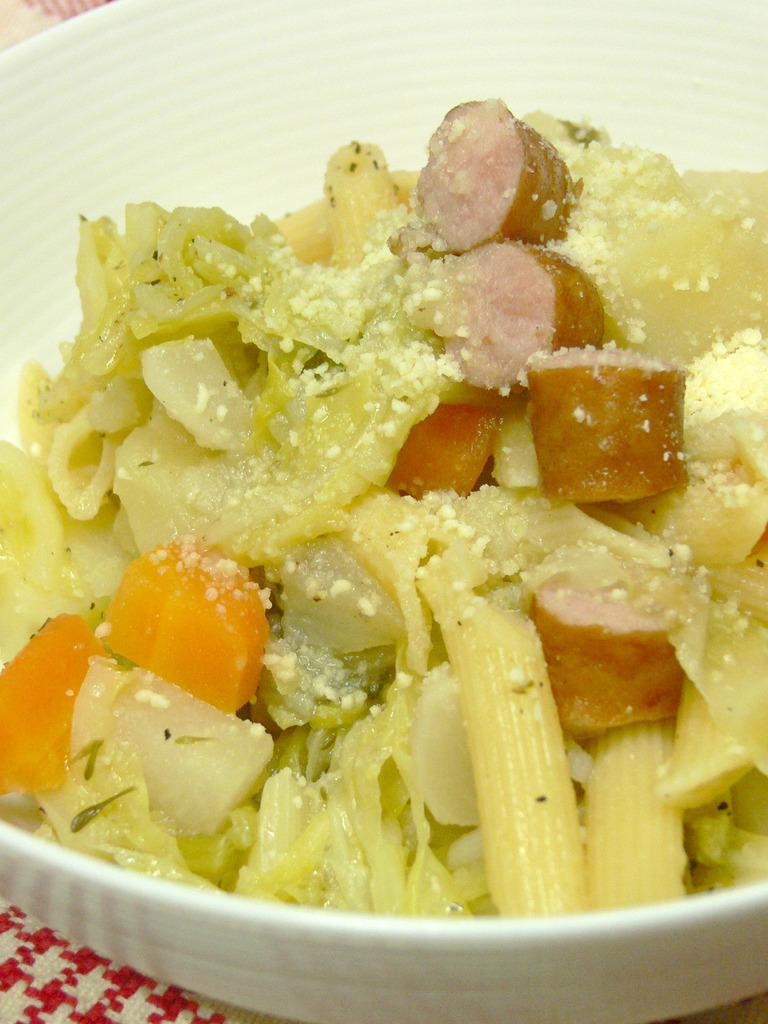What is the main piece of furniture in the image? There is a table in the image. What is placed on the table? There is a bowl on the table. What is inside the bowl? There is a food item in the bowl. What type of quill is used to stir the food in the bowl? There is no quill present in the image, and the food item does not require stirring. 